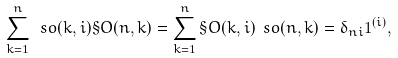Convert formula to latex. <formula><loc_0><loc_0><loc_500><loc_500>\sum _ { k = 1 } ^ { n } \ s o ( k , i ) \S O ( n , k ) = \sum _ { k = 1 } ^ { n } \S O ( k , i ) \ s o ( n , k ) = \delta _ { n i } \mathbf 1 ^ { ( i ) } ,</formula> 